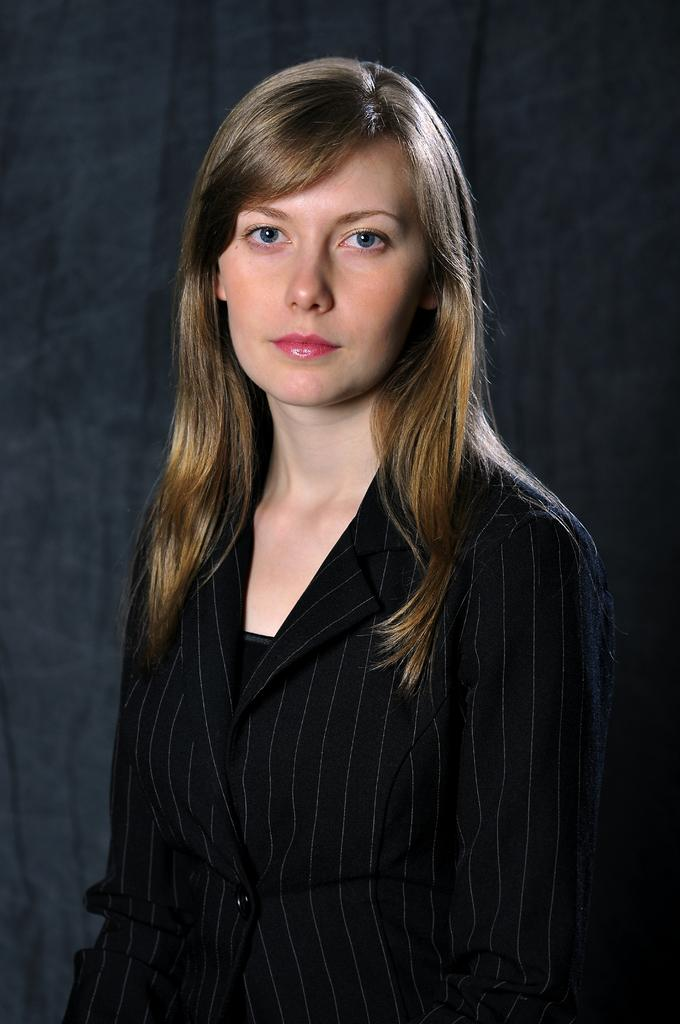What is the main subject of the image? There is a person standing in the image. What is the person wearing? The person is wearing a black dress. What can be seen in the background of the image? The background of the image is black. What type of bone can be seen in the person's hand in the image? There is no bone present in the image; the person is not holding anything. 